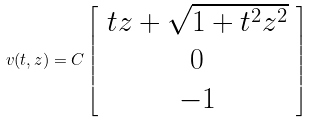<formula> <loc_0><loc_0><loc_500><loc_500>v ( t , z ) = C \left [ \begin{array} { c } t z + \sqrt { 1 + t ^ { 2 } z ^ { 2 } } \\ 0 \\ - 1 \end{array} \right ]</formula> 